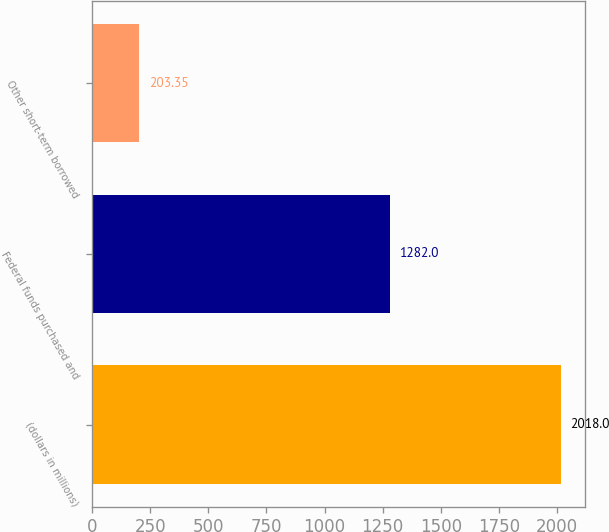<chart> <loc_0><loc_0><loc_500><loc_500><bar_chart><fcel>(dollars in millions)<fcel>Federal funds purchased and<fcel>Other short-term borrowed<nl><fcel>2018<fcel>1282<fcel>203.35<nl></chart> 